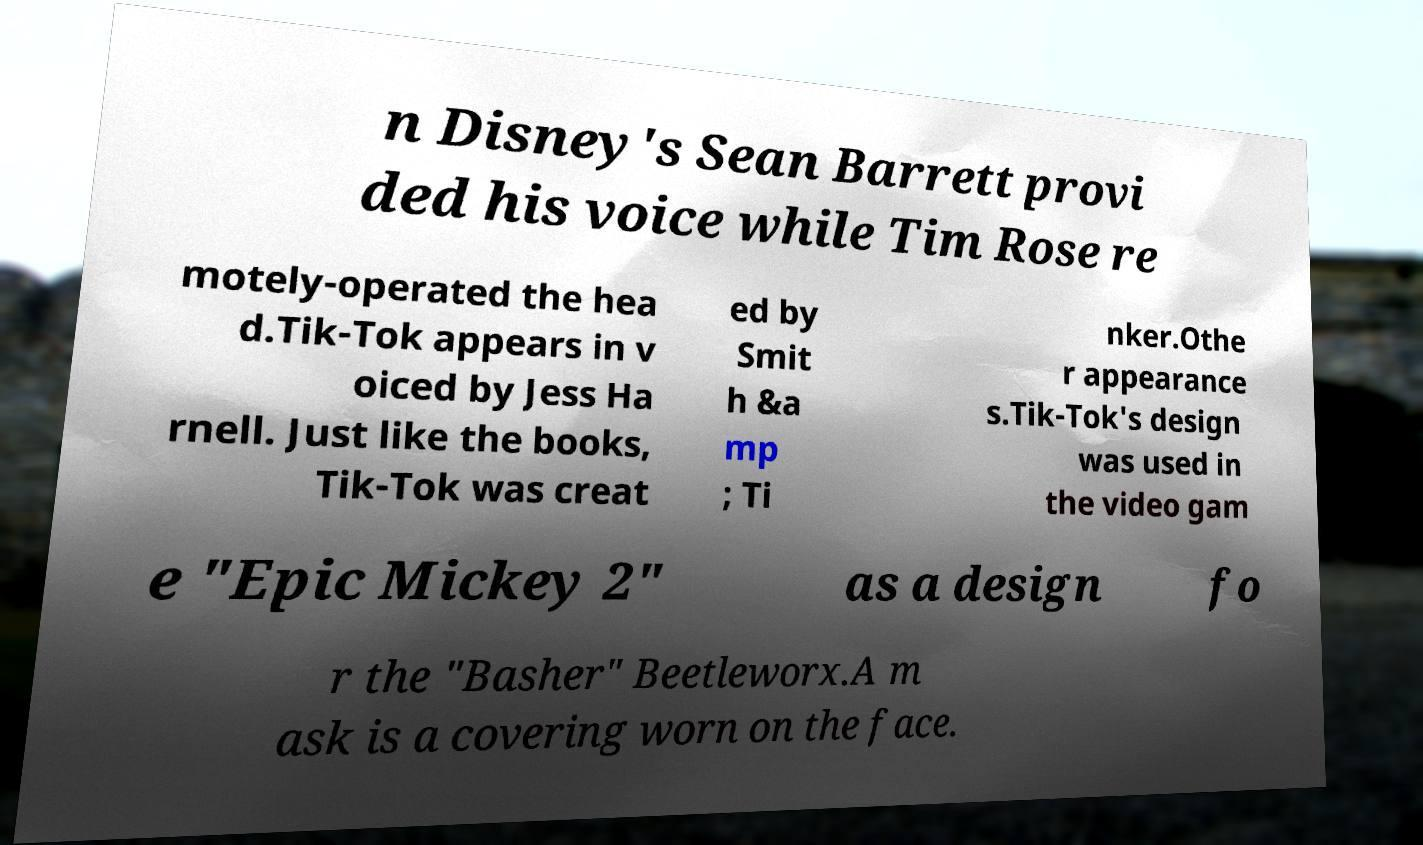Can you accurately transcribe the text from the provided image for me? n Disney's Sean Barrett provi ded his voice while Tim Rose re motely-operated the hea d.Tik-Tok appears in v oiced by Jess Ha rnell. Just like the books, Tik-Tok was creat ed by Smit h &a mp ; Ti nker.Othe r appearance s.Tik-Tok's design was used in the video gam e "Epic Mickey 2" as a design fo r the "Basher" Beetleworx.A m ask is a covering worn on the face. 